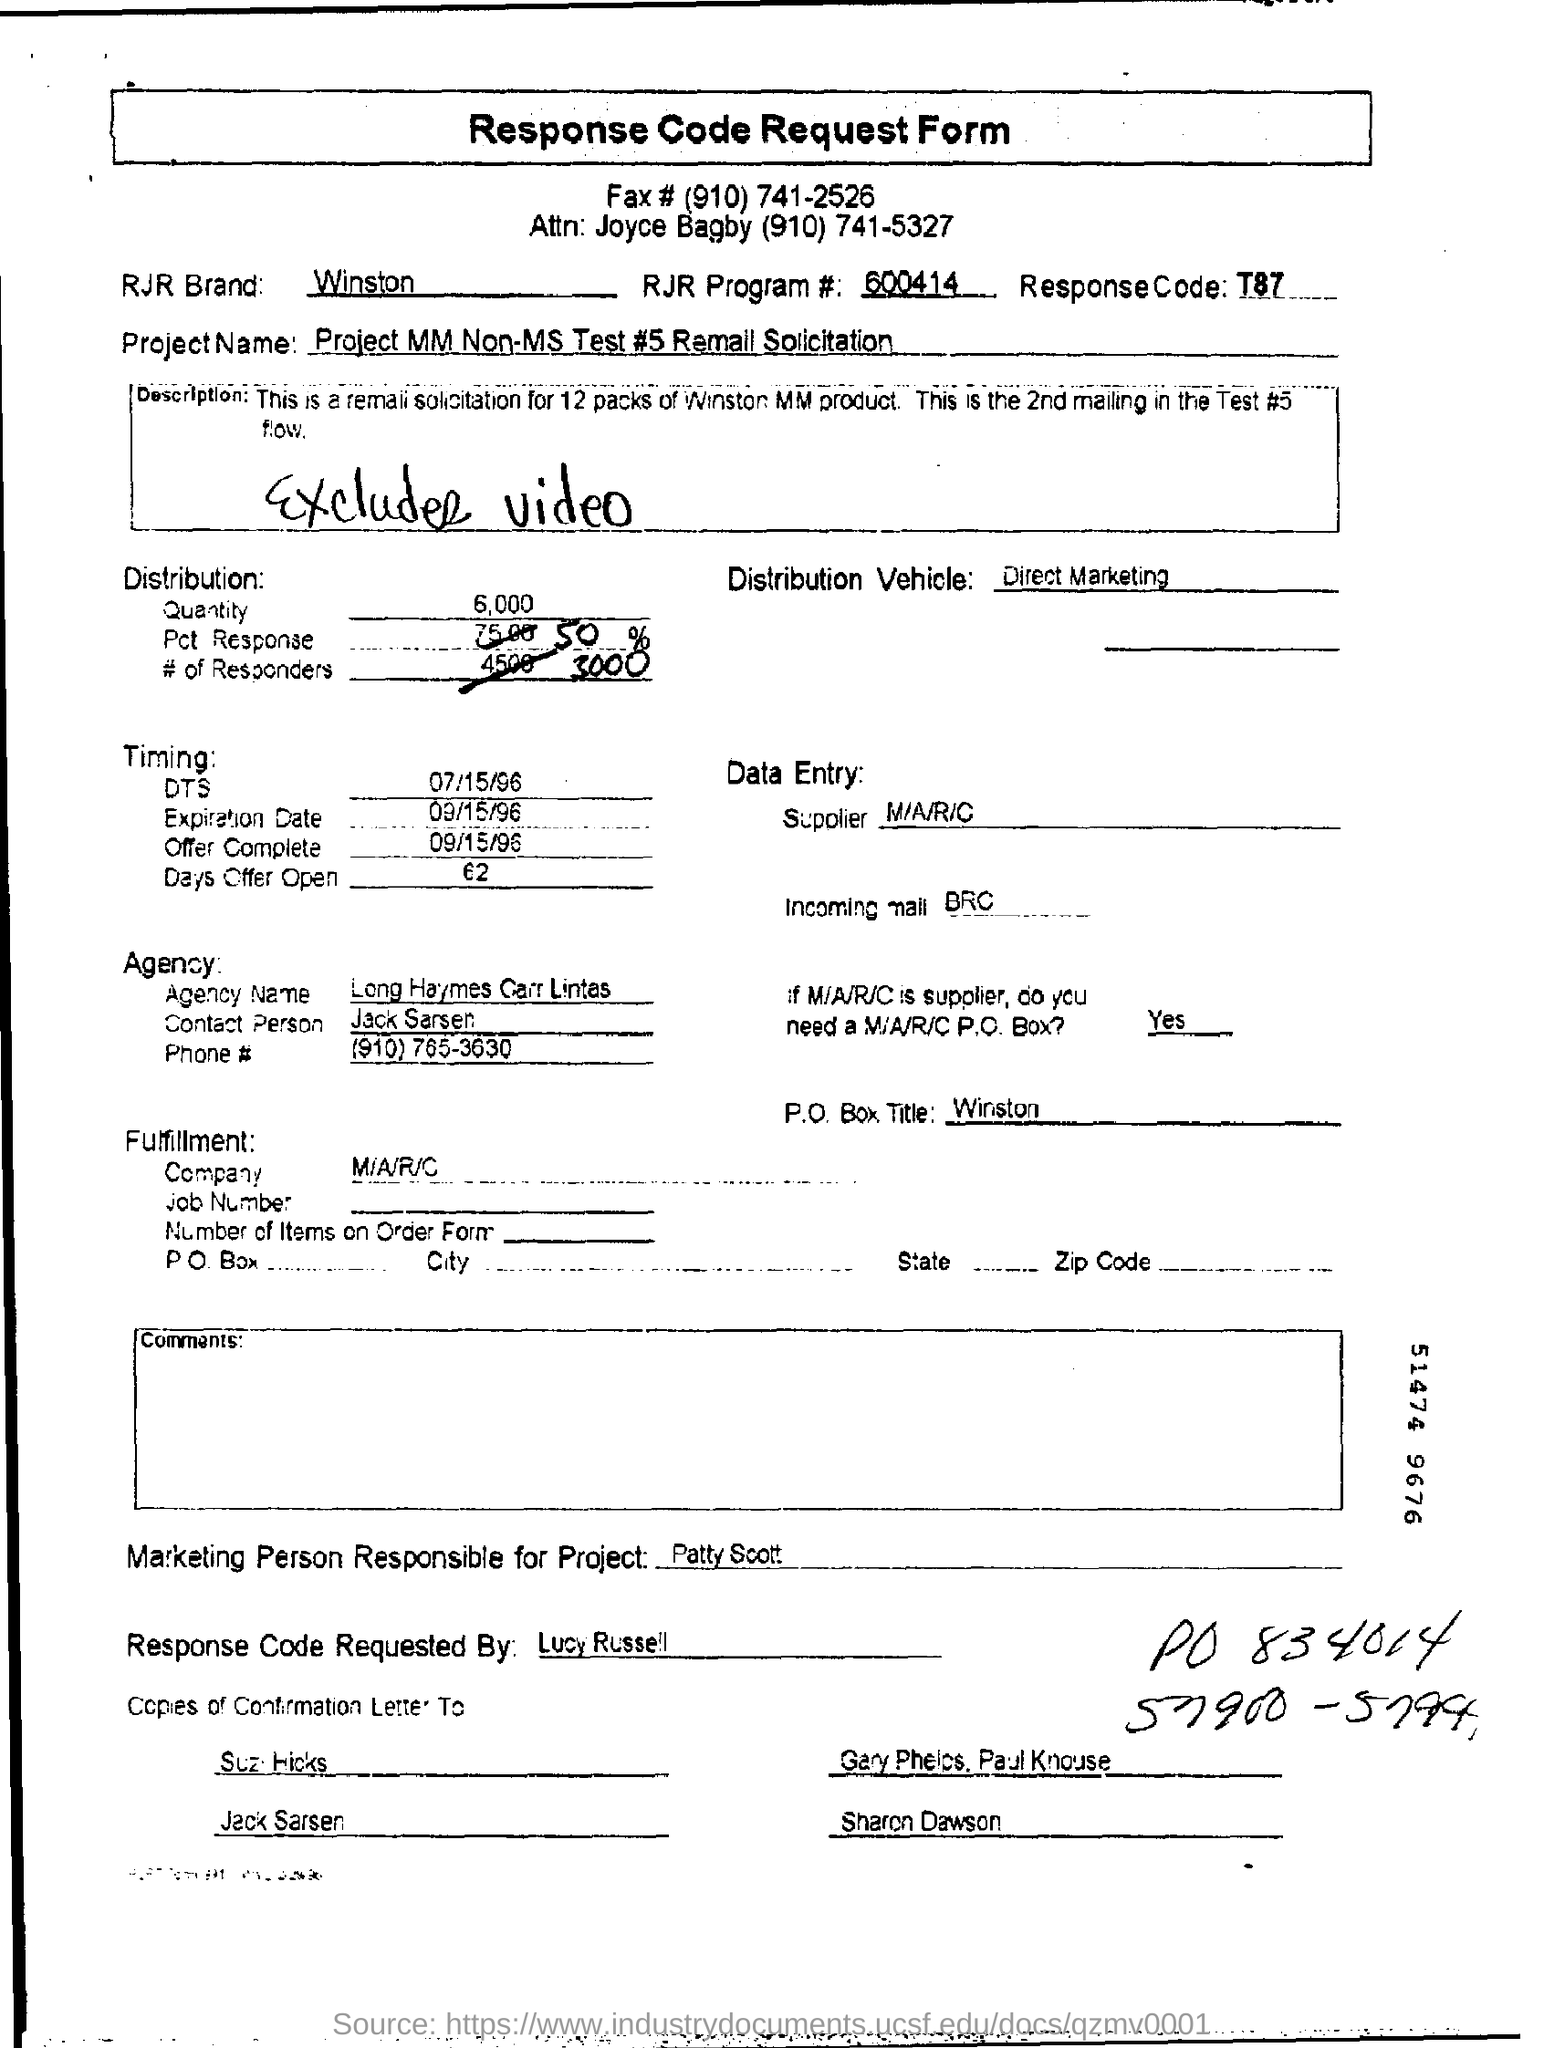Outline some significant characteristics in this image. T87 is a response code that elicits information about a specific topic. The Project Name is MM Non-MS Test #5 Remall Solicitation. The agency contact person is Jack Sarsen. The P.O Box Title is 'winston'. 